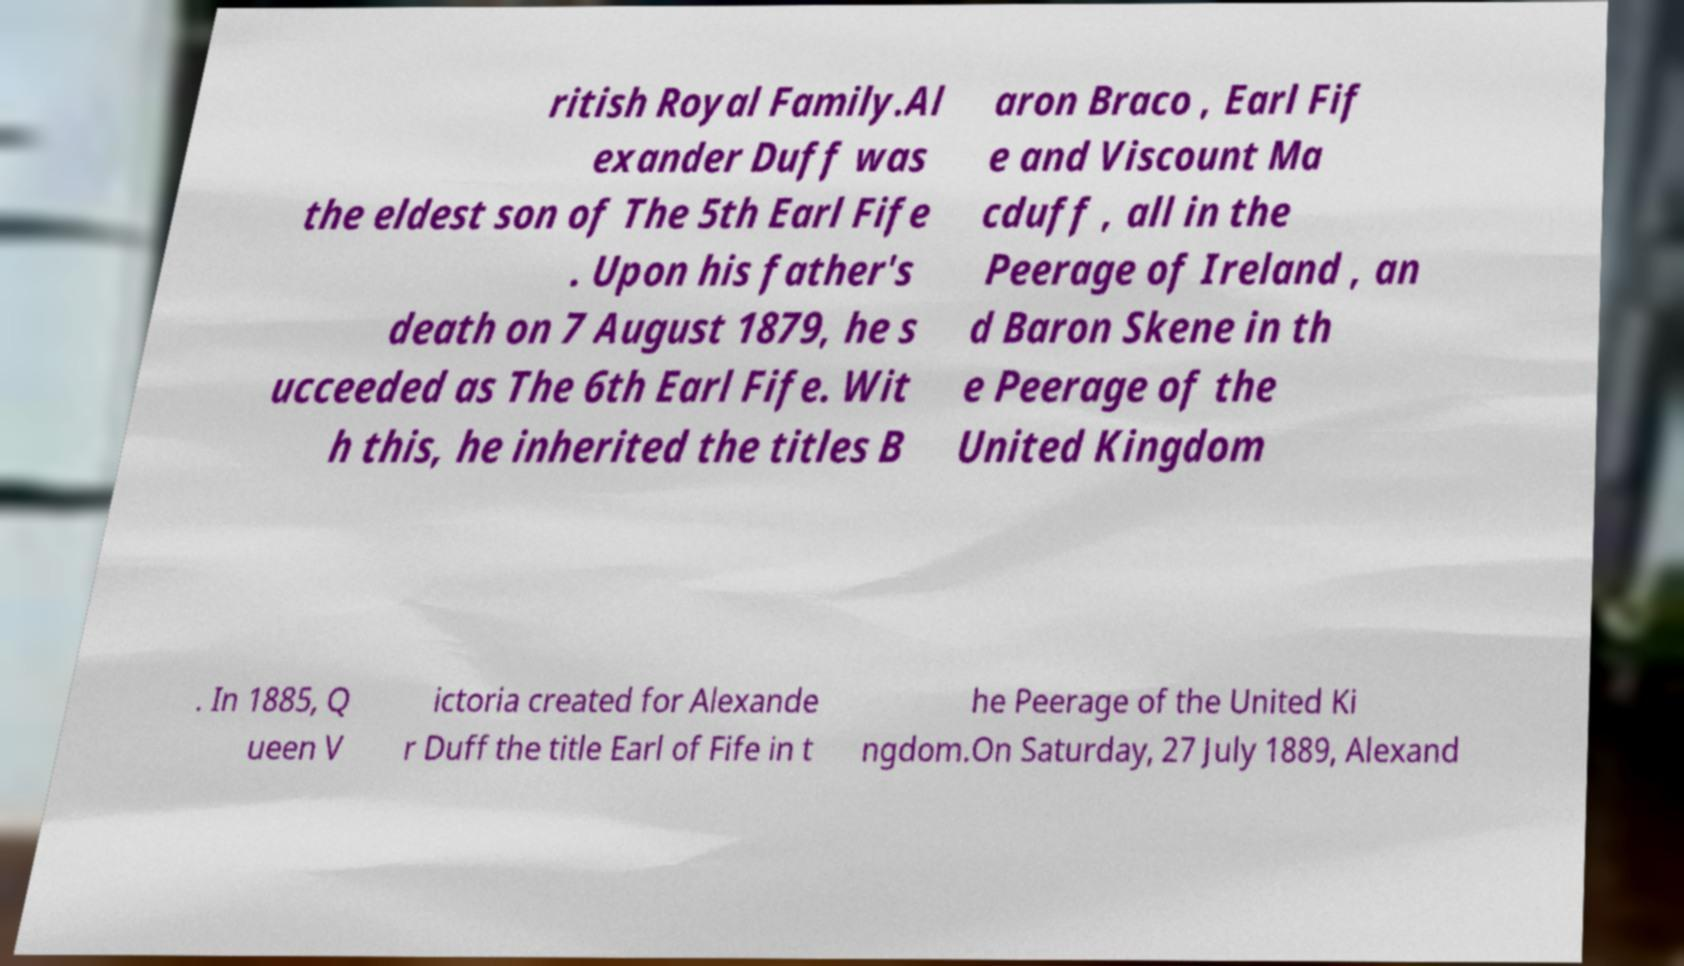Can you accurately transcribe the text from the provided image for me? ritish Royal Family.Al exander Duff was the eldest son of The 5th Earl Fife . Upon his father's death on 7 August 1879, he s ucceeded as The 6th Earl Fife. Wit h this, he inherited the titles B aron Braco , Earl Fif e and Viscount Ma cduff , all in the Peerage of Ireland , an d Baron Skene in th e Peerage of the United Kingdom . In 1885, Q ueen V ictoria created for Alexande r Duff the title Earl of Fife in t he Peerage of the United Ki ngdom.On Saturday, 27 July 1889, Alexand 